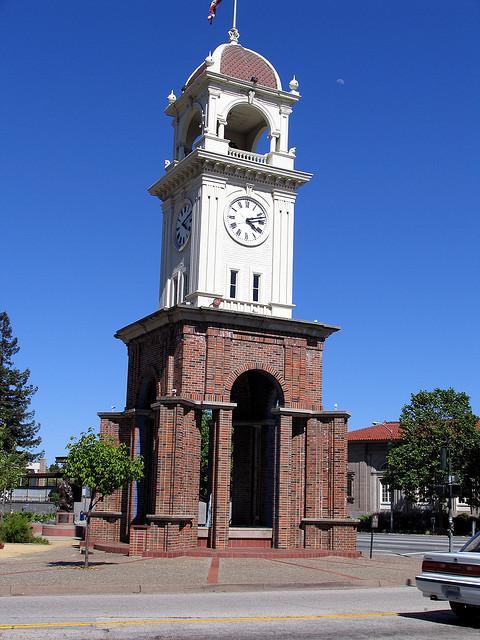What can someone know by looking at the white tower? time 